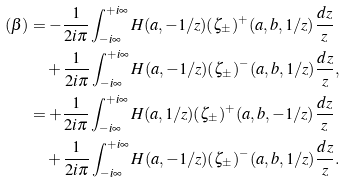<formula> <loc_0><loc_0><loc_500><loc_500>( \beta ) & = - \frac { 1 } { 2 i \pi } \int _ { - i \infty } ^ { + i \infty } H ( a , - 1 / z ) ( \zeta _ { \pm } ) ^ { + } ( a , b , 1 / z ) \frac { d z } { z } \\ & \quad + \frac { 1 } { 2 i \pi } \int _ { - i \infty } ^ { + i \infty } H ( a , - 1 / z ) ( \zeta _ { \pm } ) ^ { - } ( a , b , 1 / z ) \frac { d z } { z } , \\ & = + \frac { 1 } { 2 i \pi } \int _ { - i \infty } ^ { + i \infty } H ( a , 1 / z ) ( \zeta _ { \pm } ) ^ { + } ( a , b , - 1 / z ) \frac { d z } { z } \\ & \quad + \frac { 1 } { 2 i \pi } \int _ { - i \infty } ^ { + i \infty } H ( a , - 1 / z ) ( \zeta _ { \pm } ) ^ { - } ( a , b , 1 / z ) \frac { d z } { z } .</formula> 